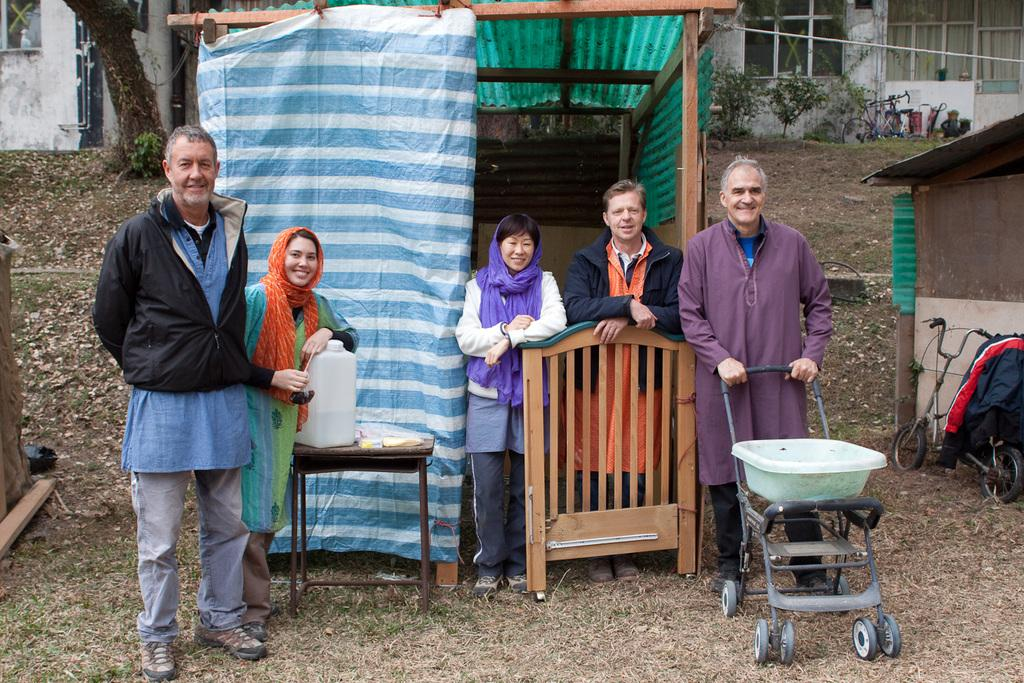How many people are present in the image? There are five people in the image. What are the people doing in the image? The people are standing and smiling. Who is holding a trolley in the image? One person is holding a trolley in the image. What can be seen in the background of the image? There is a building and plants in the background of the image. What type of hole can be seen in the image? There is no hole present in the image. What color is the underwear of the person holding the trolley? There is no underwear visible in the image, as the people are fully clothed. 